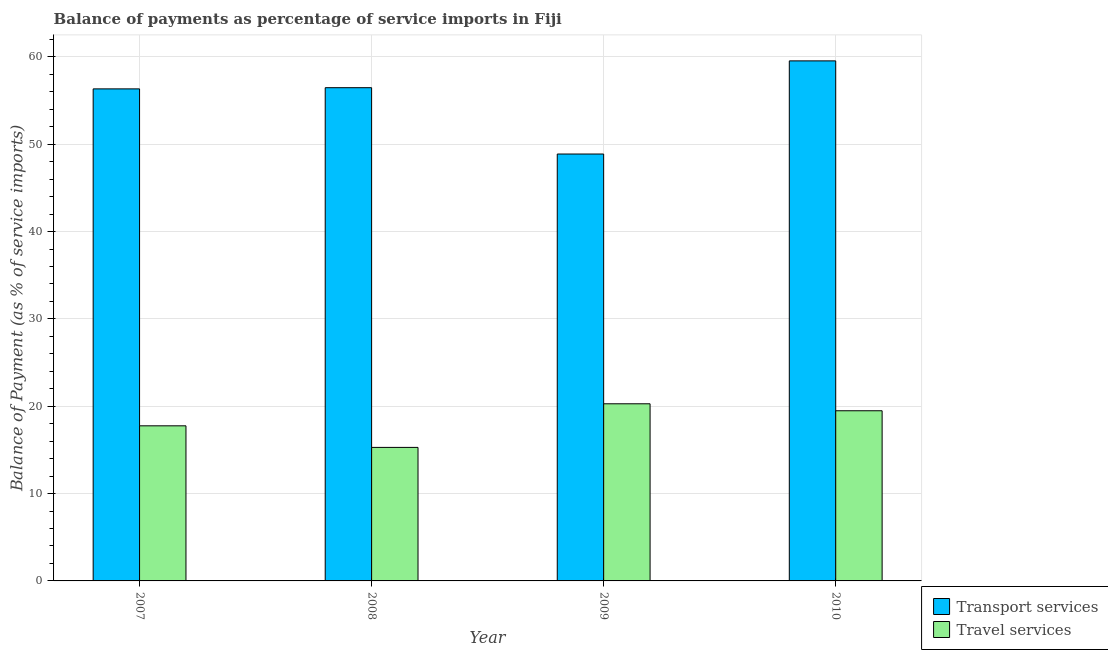How many groups of bars are there?
Give a very brief answer. 4. Are the number of bars per tick equal to the number of legend labels?
Your answer should be compact. Yes. How many bars are there on the 3rd tick from the left?
Offer a terse response. 2. How many bars are there on the 3rd tick from the right?
Your response must be concise. 2. What is the label of the 4th group of bars from the left?
Provide a succinct answer. 2010. In how many cases, is the number of bars for a given year not equal to the number of legend labels?
Make the answer very short. 0. What is the balance of payments of transport services in 2009?
Provide a short and direct response. 48.87. Across all years, what is the maximum balance of payments of travel services?
Keep it short and to the point. 20.28. Across all years, what is the minimum balance of payments of transport services?
Provide a succinct answer. 48.87. In which year was the balance of payments of travel services maximum?
Offer a very short reply. 2009. What is the total balance of payments of transport services in the graph?
Your answer should be compact. 221.21. What is the difference between the balance of payments of transport services in 2008 and that in 2010?
Your answer should be compact. -3.07. What is the difference between the balance of payments of transport services in 2008 and the balance of payments of travel services in 2010?
Your answer should be very brief. -3.07. What is the average balance of payments of travel services per year?
Ensure brevity in your answer.  18.2. In the year 2007, what is the difference between the balance of payments of travel services and balance of payments of transport services?
Provide a succinct answer. 0. What is the ratio of the balance of payments of travel services in 2008 to that in 2010?
Provide a succinct answer. 0.78. What is the difference between the highest and the second highest balance of payments of travel services?
Your response must be concise. 0.8. What is the difference between the highest and the lowest balance of payments of transport services?
Give a very brief answer. 10.66. In how many years, is the balance of payments of travel services greater than the average balance of payments of travel services taken over all years?
Provide a short and direct response. 2. What does the 2nd bar from the left in 2007 represents?
Ensure brevity in your answer.  Travel services. What does the 1st bar from the right in 2009 represents?
Ensure brevity in your answer.  Travel services. How many bars are there?
Ensure brevity in your answer.  8. Are the values on the major ticks of Y-axis written in scientific E-notation?
Your answer should be compact. No. Does the graph contain grids?
Your answer should be compact. Yes. Where does the legend appear in the graph?
Make the answer very short. Bottom right. What is the title of the graph?
Your answer should be compact. Balance of payments as percentage of service imports in Fiji. What is the label or title of the Y-axis?
Your answer should be very brief. Balance of Payment (as % of service imports). What is the Balance of Payment (as % of service imports) in Transport services in 2007?
Your response must be concise. 56.33. What is the Balance of Payment (as % of service imports) of Travel services in 2007?
Your answer should be very brief. 17.76. What is the Balance of Payment (as % of service imports) of Transport services in 2008?
Ensure brevity in your answer.  56.47. What is the Balance of Payment (as % of service imports) in Travel services in 2008?
Your answer should be compact. 15.29. What is the Balance of Payment (as % of service imports) of Transport services in 2009?
Ensure brevity in your answer.  48.87. What is the Balance of Payment (as % of service imports) in Travel services in 2009?
Offer a very short reply. 20.28. What is the Balance of Payment (as % of service imports) of Transport services in 2010?
Provide a succinct answer. 59.54. What is the Balance of Payment (as % of service imports) of Travel services in 2010?
Offer a terse response. 19.48. Across all years, what is the maximum Balance of Payment (as % of service imports) of Transport services?
Your answer should be compact. 59.54. Across all years, what is the maximum Balance of Payment (as % of service imports) in Travel services?
Your answer should be compact. 20.28. Across all years, what is the minimum Balance of Payment (as % of service imports) in Transport services?
Your answer should be very brief. 48.87. Across all years, what is the minimum Balance of Payment (as % of service imports) of Travel services?
Provide a succinct answer. 15.29. What is the total Balance of Payment (as % of service imports) in Transport services in the graph?
Ensure brevity in your answer.  221.21. What is the total Balance of Payment (as % of service imports) in Travel services in the graph?
Your answer should be compact. 72.8. What is the difference between the Balance of Payment (as % of service imports) in Transport services in 2007 and that in 2008?
Offer a very short reply. -0.14. What is the difference between the Balance of Payment (as % of service imports) in Travel services in 2007 and that in 2008?
Provide a short and direct response. 2.47. What is the difference between the Balance of Payment (as % of service imports) in Transport services in 2007 and that in 2009?
Your answer should be compact. 7.46. What is the difference between the Balance of Payment (as % of service imports) of Travel services in 2007 and that in 2009?
Your answer should be very brief. -2.52. What is the difference between the Balance of Payment (as % of service imports) in Transport services in 2007 and that in 2010?
Provide a short and direct response. -3.21. What is the difference between the Balance of Payment (as % of service imports) in Travel services in 2007 and that in 2010?
Your response must be concise. -1.73. What is the difference between the Balance of Payment (as % of service imports) of Transport services in 2008 and that in 2009?
Your answer should be very brief. 7.59. What is the difference between the Balance of Payment (as % of service imports) in Travel services in 2008 and that in 2009?
Your answer should be very brief. -4.99. What is the difference between the Balance of Payment (as % of service imports) of Transport services in 2008 and that in 2010?
Your answer should be compact. -3.07. What is the difference between the Balance of Payment (as % of service imports) of Travel services in 2008 and that in 2010?
Offer a very short reply. -4.2. What is the difference between the Balance of Payment (as % of service imports) of Transport services in 2009 and that in 2010?
Provide a short and direct response. -10.66. What is the difference between the Balance of Payment (as % of service imports) of Travel services in 2009 and that in 2010?
Provide a succinct answer. 0.8. What is the difference between the Balance of Payment (as % of service imports) in Transport services in 2007 and the Balance of Payment (as % of service imports) in Travel services in 2008?
Offer a very short reply. 41.04. What is the difference between the Balance of Payment (as % of service imports) in Transport services in 2007 and the Balance of Payment (as % of service imports) in Travel services in 2009?
Keep it short and to the point. 36.05. What is the difference between the Balance of Payment (as % of service imports) of Transport services in 2007 and the Balance of Payment (as % of service imports) of Travel services in 2010?
Provide a succinct answer. 36.85. What is the difference between the Balance of Payment (as % of service imports) in Transport services in 2008 and the Balance of Payment (as % of service imports) in Travel services in 2009?
Offer a very short reply. 36.19. What is the difference between the Balance of Payment (as % of service imports) in Transport services in 2008 and the Balance of Payment (as % of service imports) in Travel services in 2010?
Your answer should be compact. 36.99. What is the difference between the Balance of Payment (as % of service imports) in Transport services in 2009 and the Balance of Payment (as % of service imports) in Travel services in 2010?
Provide a succinct answer. 29.39. What is the average Balance of Payment (as % of service imports) in Transport services per year?
Your response must be concise. 55.3. What is the average Balance of Payment (as % of service imports) of Travel services per year?
Your answer should be compact. 18.2. In the year 2007, what is the difference between the Balance of Payment (as % of service imports) in Transport services and Balance of Payment (as % of service imports) in Travel services?
Ensure brevity in your answer.  38.57. In the year 2008, what is the difference between the Balance of Payment (as % of service imports) in Transport services and Balance of Payment (as % of service imports) in Travel services?
Make the answer very short. 41.18. In the year 2009, what is the difference between the Balance of Payment (as % of service imports) of Transport services and Balance of Payment (as % of service imports) of Travel services?
Make the answer very short. 28.6. In the year 2010, what is the difference between the Balance of Payment (as % of service imports) in Transport services and Balance of Payment (as % of service imports) in Travel services?
Provide a succinct answer. 40.06. What is the ratio of the Balance of Payment (as % of service imports) of Transport services in 2007 to that in 2008?
Provide a short and direct response. 1. What is the ratio of the Balance of Payment (as % of service imports) in Travel services in 2007 to that in 2008?
Provide a short and direct response. 1.16. What is the ratio of the Balance of Payment (as % of service imports) of Transport services in 2007 to that in 2009?
Provide a short and direct response. 1.15. What is the ratio of the Balance of Payment (as % of service imports) of Travel services in 2007 to that in 2009?
Give a very brief answer. 0.88. What is the ratio of the Balance of Payment (as % of service imports) in Transport services in 2007 to that in 2010?
Provide a short and direct response. 0.95. What is the ratio of the Balance of Payment (as % of service imports) in Travel services in 2007 to that in 2010?
Offer a very short reply. 0.91. What is the ratio of the Balance of Payment (as % of service imports) in Transport services in 2008 to that in 2009?
Provide a succinct answer. 1.16. What is the ratio of the Balance of Payment (as % of service imports) in Travel services in 2008 to that in 2009?
Provide a succinct answer. 0.75. What is the ratio of the Balance of Payment (as % of service imports) of Transport services in 2008 to that in 2010?
Offer a terse response. 0.95. What is the ratio of the Balance of Payment (as % of service imports) of Travel services in 2008 to that in 2010?
Your answer should be very brief. 0.78. What is the ratio of the Balance of Payment (as % of service imports) in Transport services in 2009 to that in 2010?
Offer a very short reply. 0.82. What is the ratio of the Balance of Payment (as % of service imports) of Travel services in 2009 to that in 2010?
Offer a terse response. 1.04. What is the difference between the highest and the second highest Balance of Payment (as % of service imports) of Transport services?
Your response must be concise. 3.07. What is the difference between the highest and the second highest Balance of Payment (as % of service imports) of Travel services?
Give a very brief answer. 0.8. What is the difference between the highest and the lowest Balance of Payment (as % of service imports) of Transport services?
Make the answer very short. 10.66. What is the difference between the highest and the lowest Balance of Payment (as % of service imports) in Travel services?
Give a very brief answer. 4.99. 